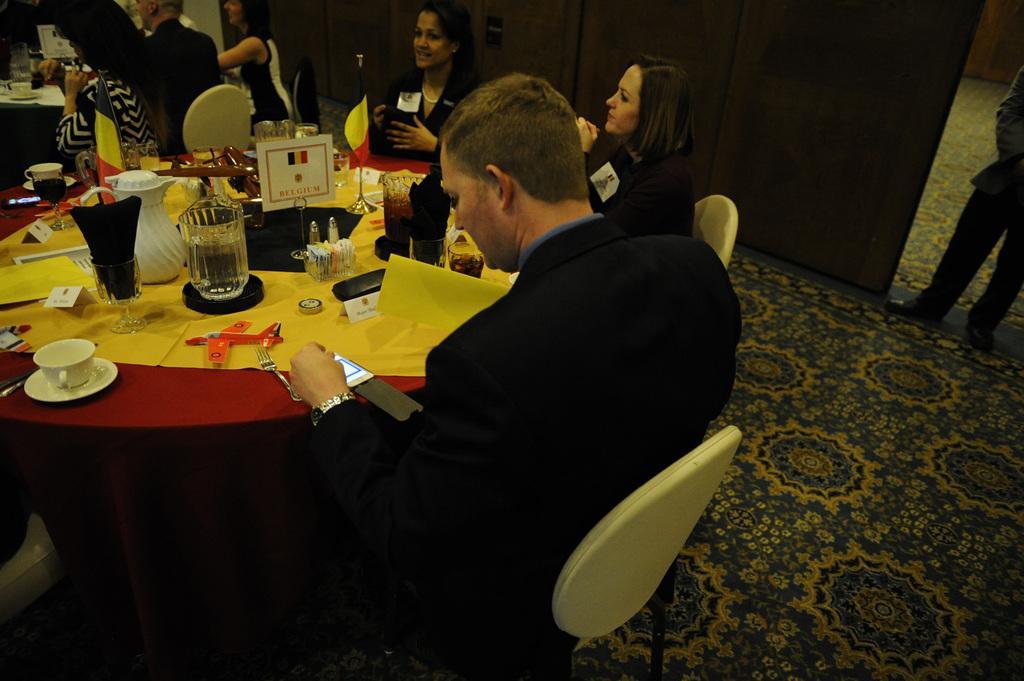Describe this image in one or two sentences. In the middle of the image there is a table, On the table there are some glasses, cup, saucer and there are some toys. In the middle of the image there is a flag on the table. Surrounding the table few people are sitting. Top right side of the image there is a person standing. At the top of the image there is a wall. 